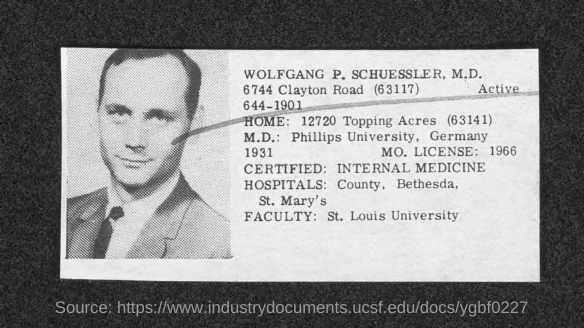What is mo. license no.?
Offer a very short reply. 1966. What is wolfgang p. schuessler, m.d. certified in ?
Offer a terse response. Internal medicine. In which university is wolfgang p. schuessler, m.d. faculty at?
Ensure brevity in your answer.  St. louis university. 